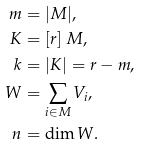<formula> <loc_0><loc_0><loc_500><loc_500>m & = | M | , \\ K & = [ r ] \ M , \\ k & = | K | = r - m , \\ W & = \sum _ { i \in M } V _ { i } , \\ n & = \dim W .</formula> 